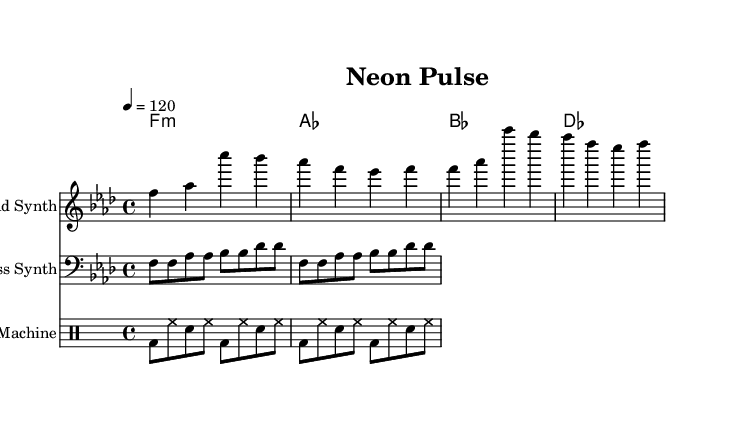What is the key signature of this music? The key signature indicated at the beginning of the piece shows two flats, which is characteristic of F minor.
Answer: F minor What is the time signature of this music? The time signature is shown at the beginning and indicates that the piece is in 4/4 time, meaning there are four beats in each measure.
Answer: 4/4 What is the tempo marking for this piece? The tempo marking is provided as "4 = 120," which means that the quarter note is set to a speed of 120 beats per minute.
Answer: 120 How many measures does the lead synth part contain? By observing the lead synth notation, there are four measures present in the provided melodic line.
Answer: 4 What type of rhythm pattern is used in the drum machine section? The drum machine section demonstrates a standard backbeat rhythm with bass drum on the first beat and snare on the third, creating a driving electronic groove.
Answer: Backbeat What is the highest pitch of the lead synth melody? The highest pitch in the lead synth part is the note C', which occurs at the start of the first measure.
Answer: C' Which chord is played on the first beat of the first measure? Looking at the chord above the staff, the first chord played is F minor, as indicated by "f1:m" in the harmony section.
Answer: F minor 